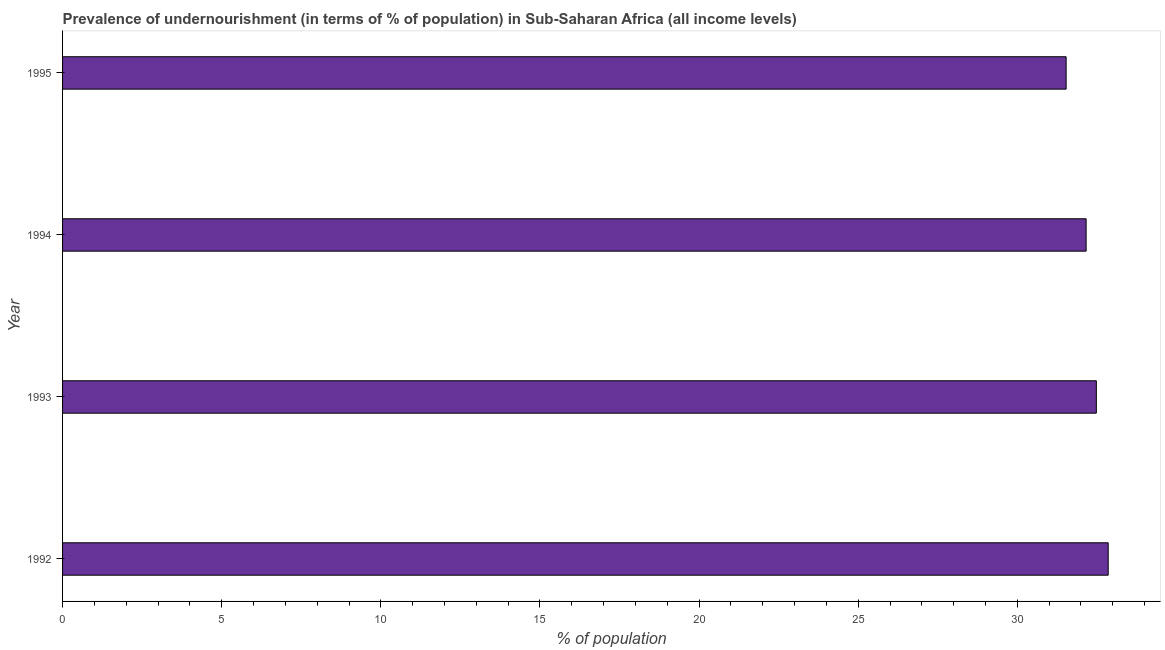Does the graph contain any zero values?
Your answer should be compact. No. What is the title of the graph?
Offer a terse response. Prevalence of undernourishment (in terms of % of population) in Sub-Saharan Africa (all income levels). What is the label or title of the X-axis?
Make the answer very short. % of population. What is the percentage of undernourished population in 1995?
Offer a terse response. 31.53. Across all years, what is the maximum percentage of undernourished population?
Ensure brevity in your answer.  32.86. Across all years, what is the minimum percentage of undernourished population?
Your answer should be very brief. 31.53. In which year was the percentage of undernourished population maximum?
Ensure brevity in your answer.  1992. What is the sum of the percentage of undernourished population?
Keep it short and to the point. 129.03. What is the difference between the percentage of undernourished population in 1993 and 1994?
Your answer should be compact. 0.32. What is the average percentage of undernourished population per year?
Your response must be concise. 32.26. What is the median percentage of undernourished population?
Give a very brief answer. 32.32. What is the ratio of the percentage of undernourished population in 1993 to that in 1994?
Provide a succinct answer. 1.01. Is the difference between the percentage of undernourished population in 1992 and 1993 greater than the difference between any two years?
Your answer should be very brief. No. What is the difference between the highest and the second highest percentage of undernourished population?
Keep it short and to the point. 0.37. Is the sum of the percentage of undernourished population in 1993 and 1994 greater than the maximum percentage of undernourished population across all years?
Provide a short and direct response. Yes. What is the difference between the highest and the lowest percentage of undernourished population?
Provide a short and direct response. 1.32. How many bars are there?
Make the answer very short. 4. Are all the bars in the graph horizontal?
Provide a succinct answer. Yes. What is the difference between two consecutive major ticks on the X-axis?
Make the answer very short. 5. What is the % of population of 1992?
Keep it short and to the point. 32.86. What is the % of population of 1993?
Offer a terse response. 32.48. What is the % of population in 1994?
Ensure brevity in your answer.  32.16. What is the % of population in 1995?
Your answer should be very brief. 31.53. What is the difference between the % of population in 1992 and 1993?
Your answer should be very brief. 0.37. What is the difference between the % of population in 1992 and 1994?
Your answer should be compact. 0.69. What is the difference between the % of population in 1992 and 1995?
Your response must be concise. 1.32. What is the difference between the % of population in 1993 and 1994?
Your response must be concise. 0.32. What is the difference between the % of population in 1993 and 1995?
Provide a succinct answer. 0.95. What is the difference between the % of population in 1994 and 1995?
Your response must be concise. 0.63. What is the ratio of the % of population in 1992 to that in 1995?
Make the answer very short. 1.04. 